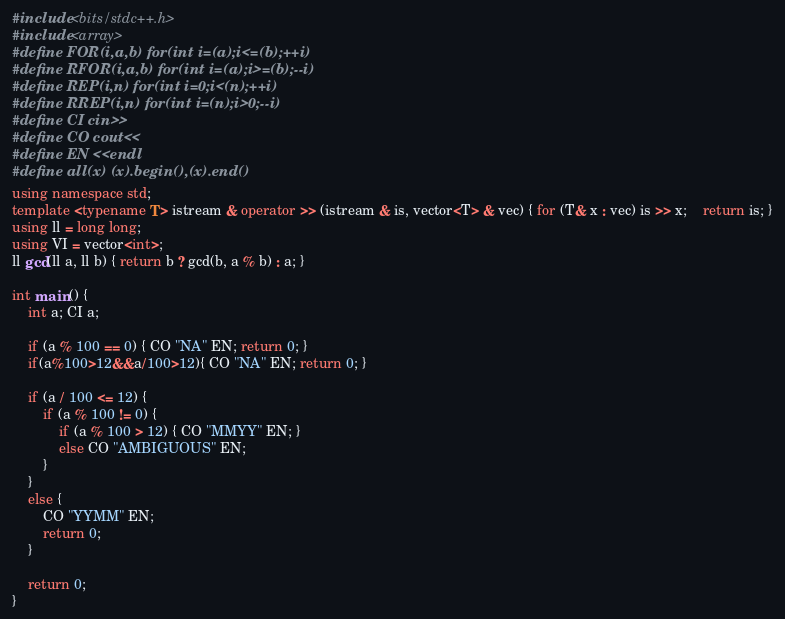<code> <loc_0><loc_0><loc_500><loc_500><_C++_>#include <bits/stdc++.h>
#include <array>
#define FOR(i,a,b) for(int i=(a);i<=(b);++i) 
#define RFOR(i,a,b) for(int i=(a);i>=(b);--i) 
#define REP(i,n) for(int i=0;i<(n);++i)
#define RREP(i,n) for(int i=(n);i>0;--i)
#define CI cin>> 
#define CO cout<<
#define EN <<endl 
#define all(x) (x).begin(),(x).end() 
using namespace std;
template <typename T> istream & operator >> (istream & is, vector<T> & vec) { for (T& x : vec) is >> x; 	return is; }
using ll = long long;
using VI = vector<int>;
ll gcd(ll a, ll b) { return b ? gcd(b, a % b) : a; }

int main() {
	int a; CI a;

	if (a % 100 == 0) { CO "NA" EN; return 0; }
	if(a%100>12&&a/100>12){ CO "NA" EN; return 0; }

	if (a / 100 <= 12) {
		if (a % 100 != 0) {
			if (a % 100 > 12) { CO "MMYY" EN; }
			else CO "AMBIGUOUS" EN;
		}
	}
	else {
		CO "YYMM" EN;
		return 0;
	}

	return 0;
}</code> 